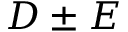<formula> <loc_0><loc_0><loc_500><loc_500>D \pm E</formula> 